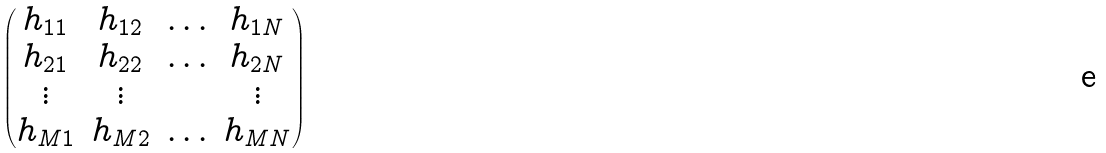Convert formula to latex. <formula><loc_0><loc_0><loc_500><loc_500>\begin{pmatrix} h _ { 1 1 } & h _ { 1 2 } & \hdots & h _ { 1 N } \\ h _ { 2 1 } & h _ { 2 2 } & \hdots & h _ { 2 N } \\ \vdots & \vdots & & \vdots \\ h _ { M 1 } & h _ { M 2 } & \hdots & h _ { M N } \end{pmatrix}</formula> 